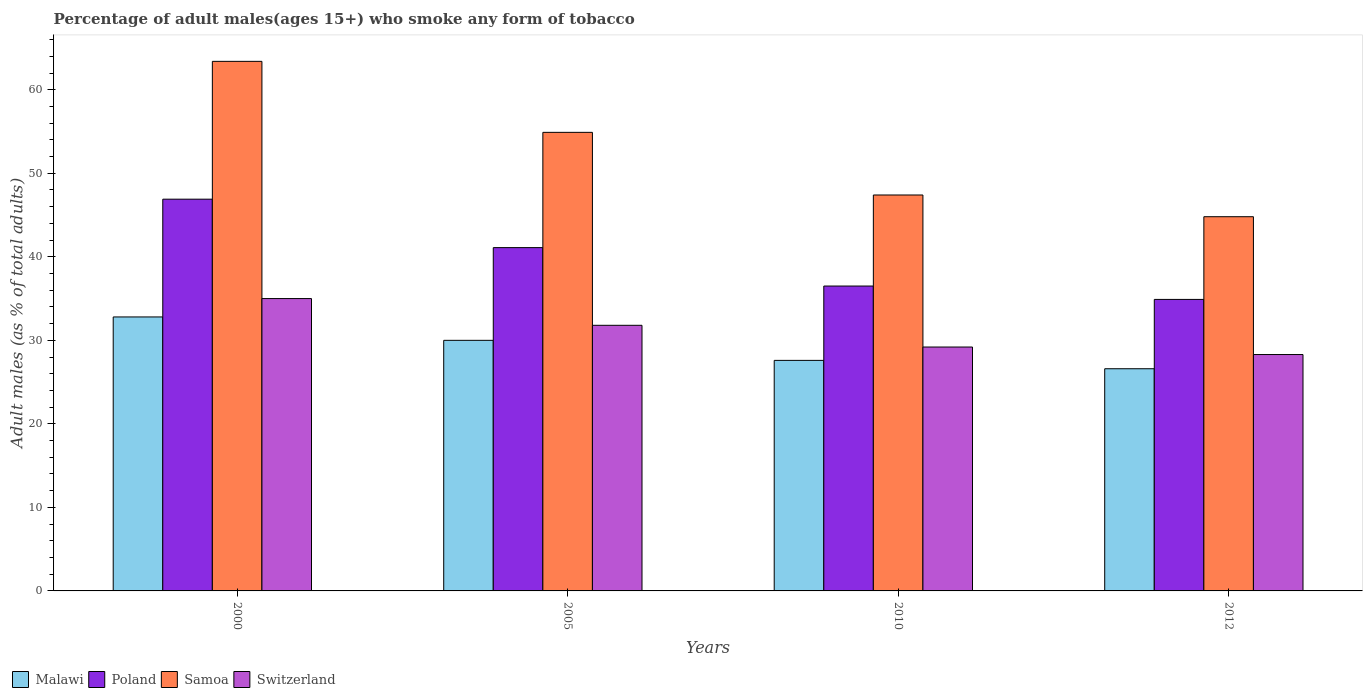How many groups of bars are there?
Give a very brief answer. 4. Are the number of bars on each tick of the X-axis equal?
Keep it short and to the point. Yes. How many bars are there on the 1st tick from the right?
Offer a very short reply. 4. What is the percentage of adult males who smoke in Samoa in 2012?
Ensure brevity in your answer.  44.8. Across all years, what is the minimum percentage of adult males who smoke in Samoa?
Keep it short and to the point. 44.8. In which year was the percentage of adult males who smoke in Switzerland minimum?
Your answer should be very brief. 2012. What is the total percentage of adult males who smoke in Switzerland in the graph?
Provide a succinct answer. 124.3. What is the difference between the percentage of adult males who smoke in Poland in 2000 and that in 2005?
Keep it short and to the point. 5.8. What is the difference between the percentage of adult males who smoke in Malawi in 2000 and the percentage of adult males who smoke in Switzerland in 2005?
Make the answer very short. 1. What is the average percentage of adult males who smoke in Samoa per year?
Offer a terse response. 52.62. What is the ratio of the percentage of adult males who smoke in Switzerland in 2005 to that in 2012?
Provide a short and direct response. 1.12. What is the difference between the highest and the second highest percentage of adult males who smoke in Poland?
Your answer should be compact. 5.8. What is the difference between the highest and the lowest percentage of adult males who smoke in Switzerland?
Your answer should be compact. 6.7. What does the 2nd bar from the right in 2012 represents?
Provide a succinct answer. Samoa. Is it the case that in every year, the sum of the percentage of adult males who smoke in Malawi and percentage of adult males who smoke in Samoa is greater than the percentage of adult males who smoke in Switzerland?
Keep it short and to the point. Yes. How many bars are there?
Give a very brief answer. 16. Are all the bars in the graph horizontal?
Your answer should be very brief. No. Are the values on the major ticks of Y-axis written in scientific E-notation?
Provide a short and direct response. No. Does the graph contain any zero values?
Ensure brevity in your answer.  No. What is the title of the graph?
Provide a short and direct response. Percentage of adult males(ages 15+) who smoke any form of tobacco. What is the label or title of the X-axis?
Offer a very short reply. Years. What is the label or title of the Y-axis?
Offer a very short reply. Adult males (as % of total adults). What is the Adult males (as % of total adults) in Malawi in 2000?
Make the answer very short. 32.8. What is the Adult males (as % of total adults) of Poland in 2000?
Your answer should be very brief. 46.9. What is the Adult males (as % of total adults) in Samoa in 2000?
Make the answer very short. 63.4. What is the Adult males (as % of total adults) in Malawi in 2005?
Keep it short and to the point. 30. What is the Adult males (as % of total adults) in Poland in 2005?
Ensure brevity in your answer.  41.1. What is the Adult males (as % of total adults) in Samoa in 2005?
Offer a very short reply. 54.9. What is the Adult males (as % of total adults) of Switzerland in 2005?
Give a very brief answer. 31.8. What is the Adult males (as % of total adults) of Malawi in 2010?
Offer a very short reply. 27.6. What is the Adult males (as % of total adults) of Poland in 2010?
Offer a very short reply. 36.5. What is the Adult males (as % of total adults) in Samoa in 2010?
Provide a short and direct response. 47.4. What is the Adult males (as % of total adults) of Switzerland in 2010?
Offer a very short reply. 29.2. What is the Adult males (as % of total adults) of Malawi in 2012?
Your answer should be compact. 26.6. What is the Adult males (as % of total adults) of Poland in 2012?
Offer a very short reply. 34.9. What is the Adult males (as % of total adults) in Samoa in 2012?
Offer a very short reply. 44.8. What is the Adult males (as % of total adults) of Switzerland in 2012?
Offer a terse response. 28.3. Across all years, what is the maximum Adult males (as % of total adults) of Malawi?
Provide a short and direct response. 32.8. Across all years, what is the maximum Adult males (as % of total adults) in Poland?
Provide a succinct answer. 46.9. Across all years, what is the maximum Adult males (as % of total adults) in Samoa?
Offer a very short reply. 63.4. Across all years, what is the minimum Adult males (as % of total adults) of Malawi?
Give a very brief answer. 26.6. Across all years, what is the minimum Adult males (as % of total adults) of Poland?
Offer a very short reply. 34.9. Across all years, what is the minimum Adult males (as % of total adults) of Samoa?
Keep it short and to the point. 44.8. Across all years, what is the minimum Adult males (as % of total adults) in Switzerland?
Your answer should be compact. 28.3. What is the total Adult males (as % of total adults) of Malawi in the graph?
Keep it short and to the point. 117. What is the total Adult males (as % of total adults) in Poland in the graph?
Offer a very short reply. 159.4. What is the total Adult males (as % of total adults) in Samoa in the graph?
Provide a short and direct response. 210.5. What is the total Adult males (as % of total adults) of Switzerland in the graph?
Offer a very short reply. 124.3. What is the difference between the Adult males (as % of total adults) in Poland in 2000 and that in 2005?
Provide a short and direct response. 5.8. What is the difference between the Adult males (as % of total adults) of Switzerland in 2000 and that in 2005?
Keep it short and to the point. 3.2. What is the difference between the Adult males (as % of total adults) of Poland in 2000 and that in 2010?
Provide a succinct answer. 10.4. What is the difference between the Adult males (as % of total adults) of Samoa in 2000 and that in 2010?
Provide a succinct answer. 16. What is the difference between the Adult males (as % of total adults) in Switzerland in 2000 and that in 2010?
Give a very brief answer. 5.8. What is the difference between the Adult males (as % of total adults) of Malawi in 2000 and that in 2012?
Offer a very short reply. 6.2. What is the difference between the Adult males (as % of total adults) in Malawi in 2005 and that in 2010?
Give a very brief answer. 2.4. What is the difference between the Adult males (as % of total adults) of Switzerland in 2005 and that in 2010?
Your answer should be very brief. 2.6. What is the difference between the Adult males (as % of total adults) of Samoa in 2005 and that in 2012?
Keep it short and to the point. 10.1. What is the difference between the Adult males (as % of total adults) of Switzerland in 2005 and that in 2012?
Offer a very short reply. 3.5. What is the difference between the Adult males (as % of total adults) of Malawi in 2010 and that in 2012?
Your answer should be compact. 1. What is the difference between the Adult males (as % of total adults) in Samoa in 2010 and that in 2012?
Make the answer very short. 2.6. What is the difference between the Adult males (as % of total adults) of Malawi in 2000 and the Adult males (as % of total adults) of Poland in 2005?
Ensure brevity in your answer.  -8.3. What is the difference between the Adult males (as % of total adults) of Malawi in 2000 and the Adult males (as % of total adults) of Samoa in 2005?
Keep it short and to the point. -22.1. What is the difference between the Adult males (as % of total adults) of Malawi in 2000 and the Adult males (as % of total adults) of Switzerland in 2005?
Your response must be concise. 1. What is the difference between the Adult males (as % of total adults) of Poland in 2000 and the Adult males (as % of total adults) of Samoa in 2005?
Your answer should be very brief. -8. What is the difference between the Adult males (as % of total adults) in Samoa in 2000 and the Adult males (as % of total adults) in Switzerland in 2005?
Your answer should be compact. 31.6. What is the difference between the Adult males (as % of total adults) of Malawi in 2000 and the Adult males (as % of total adults) of Poland in 2010?
Your answer should be very brief. -3.7. What is the difference between the Adult males (as % of total adults) in Malawi in 2000 and the Adult males (as % of total adults) in Samoa in 2010?
Provide a succinct answer. -14.6. What is the difference between the Adult males (as % of total adults) of Malawi in 2000 and the Adult males (as % of total adults) of Switzerland in 2010?
Ensure brevity in your answer.  3.6. What is the difference between the Adult males (as % of total adults) of Poland in 2000 and the Adult males (as % of total adults) of Samoa in 2010?
Keep it short and to the point. -0.5. What is the difference between the Adult males (as % of total adults) in Poland in 2000 and the Adult males (as % of total adults) in Switzerland in 2010?
Your response must be concise. 17.7. What is the difference between the Adult males (as % of total adults) in Samoa in 2000 and the Adult males (as % of total adults) in Switzerland in 2010?
Offer a very short reply. 34.2. What is the difference between the Adult males (as % of total adults) in Malawi in 2000 and the Adult males (as % of total adults) in Samoa in 2012?
Provide a succinct answer. -12. What is the difference between the Adult males (as % of total adults) in Malawi in 2000 and the Adult males (as % of total adults) in Switzerland in 2012?
Offer a terse response. 4.5. What is the difference between the Adult males (as % of total adults) in Poland in 2000 and the Adult males (as % of total adults) in Samoa in 2012?
Keep it short and to the point. 2.1. What is the difference between the Adult males (as % of total adults) of Samoa in 2000 and the Adult males (as % of total adults) of Switzerland in 2012?
Give a very brief answer. 35.1. What is the difference between the Adult males (as % of total adults) of Malawi in 2005 and the Adult males (as % of total adults) of Poland in 2010?
Offer a terse response. -6.5. What is the difference between the Adult males (as % of total adults) in Malawi in 2005 and the Adult males (as % of total adults) in Samoa in 2010?
Provide a short and direct response. -17.4. What is the difference between the Adult males (as % of total adults) in Poland in 2005 and the Adult males (as % of total adults) in Switzerland in 2010?
Your answer should be compact. 11.9. What is the difference between the Adult males (as % of total adults) of Samoa in 2005 and the Adult males (as % of total adults) of Switzerland in 2010?
Provide a short and direct response. 25.7. What is the difference between the Adult males (as % of total adults) in Malawi in 2005 and the Adult males (as % of total adults) in Poland in 2012?
Your answer should be very brief. -4.9. What is the difference between the Adult males (as % of total adults) in Malawi in 2005 and the Adult males (as % of total adults) in Samoa in 2012?
Offer a terse response. -14.8. What is the difference between the Adult males (as % of total adults) of Malawi in 2005 and the Adult males (as % of total adults) of Switzerland in 2012?
Provide a succinct answer. 1.7. What is the difference between the Adult males (as % of total adults) in Poland in 2005 and the Adult males (as % of total adults) in Switzerland in 2012?
Your answer should be very brief. 12.8. What is the difference between the Adult males (as % of total adults) in Samoa in 2005 and the Adult males (as % of total adults) in Switzerland in 2012?
Provide a short and direct response. 26.6. What is the difference between the Adult males (as % of total adults) of Malawi in 2010 and the Adult males (as % of total adults) of Samoa in 2012?
Keep it short and to the point. -17.2. What is the difference between the Adult males (as % of total adults) of Malawi in 2010 and the Adult males (as % of total adults) of Switzerland in 2012?
Offer a terse response. -0.7. What is the difference between the Adult males (as % of total adults) of Poland in 2010 and the Adult males (as % of total adults) of Samoa in 2012?
Give a very brief answer. -8.3. What is the difference between the Adult males (as % of total adults) in Poland in 2010 and the Adult males (as % of total adults) in Switzerland in 2012?
Make the answer very short. 8.2. What is the average Adult males (as % of total adults) in Malawi per year?
Your response must be concise. 29.25. What is the average Adult males (as % of total adults) of Poland per year?
Offer a terse response. 39.85. What is the average Adult males (as % of total adults) in Samoa per year?
Make the answer very short. 52.62. What is the average Adult males (as % of total adults) of Switzerland per year?
Your answer should be very brief. 31.07. In the year 2000, what is the difference between the Adult males (as % of total adults) in Malawi and Adult males (as % of total adults) in Poland?
Your response must be concise. -14.1. In the year 2000, what is the difference between the Adult males (as % of total adults) of Malawi and Adult males (as % of total adults) of Samoa?
Provide a short and direct response. -30.6. In the year 2000, what is the difference between the Adult males (as % of total adults) in Malawi and Adult males (as % of total adults) in Switzerland?
Make the answer very short. -2.2. In the year 2000, what is the difference between the Adult males (as % of total adults) in Poland and Adult males (as % of total adults) in Samoa?
Your response must be concise. -16.5. In the year 2000, what is the difference between the Adult males (as % of total adults) in Poland and Adult males (as % of total adults) in Switzerland?
Offer a terse response. 11.9. In the year 2000, what is the difference between the Adult males (as % of total adults) in Samoa and Adult males (as % of total adults) in Switzerland?
Give a very brief answer. 28.4. In the year 2005, what is the difference between the Adult males (as % of total adults) of Malawi and Adult males (as % of total adults) of Samoa?
Offer a very short reply. -24.9. In the year 2005, what is the difference between the Adult males (as % of total adults) of Malawi and Adult males (as % of total adults) of Switzerland?
Ensure brevity in your answer.  -1.8. In the year 2005, what is the difference between the Adult males (as % of total adults) in Samoa and Adult males (as % of total adults) in Switzerland?
Provide a short and direct response. 23.1. In the year 2010, what is the difference between the Adult males (as % of total adults) in Malawi and Adult males (as % of total adults) in Samoa?
Your response must be concise. -19.8. In the year 2010, what is the difference between the Adult males (as % of total adults) of Malawi and Adult males (as % of total adults) of Switzerland?
Your answer should be compact. -1.6. In the year 2010, what is the difference between the Adult males (as % of total adults) in Samoa and Adult males (as % of total adults) in Switzerland?
Your answer should be very brief. 18.2. In the year 2012, what is the difference between the Adult males (as % of total adults) in Malawi and Adult males (as % of total adults) in Samoa?
Your answer should be very brief. -18.2. In the year 2012, what is the difference between the Adult males (as % of total adults) in Poland and Adult males (as % of total adults) in Switzerland?
Offer a very short reply. 6.6. What is the ratio of the Adult males (as % of total adults) of Malawi in 2000 to that in 2005?
Provide a short and direct response. 1.09. What is the ratio of the Adult males (as % of total adults) in Poland in 2000 to that in 2005?
Provide a short and direct response. 1.14. What is the ratio of the Adult males (as % of total adults) of Samoa in 2000 to that in 2005?
Keep it short and to the point. 1.15. What is the ratio of the Adult males (as % of total adults) in Switzerland in 2000 to that in 2005?
Keep it short and to the point. 1.1. What is the ratio of the Adult males (as % of total adults) of Malawi in 2000 to that in 2010?
Give a very brief answer. 1.19. What is the ratio of the Adult males (as % of total adults) of Poland in 2000 to that in 2010?
Your response must be concise. 1.28. What is the ratio of the Adult males (as % of total adults) of Samoa in 2000 to that in 2010?
Your answer should be very brief. 1.34. What is the ratio of the Adult males (as % of total adults) in Switzerland in 2000 to that in 2010?
Offer a very short reply. 1.2. What is the ratio of the Adult males (as % of total adults) of Malawi in 2000 to that in 2012?
Provide a succinct answer. 1.23. What is the ratio of the Adult males (as % of total adults) in Poland in 2000 to that in 2012?
Your answer should be very brief. 1.34. What is the ratio of the Adult males (as % of total adults) of Samoa in 2000 to that in 2012?
Offer a terse response. 1.42. What is the ratio of the Adult males (as % of total adults) in Switzerland in 2000 to that in 2012?
Give a very brief answer. 1.24. What is the ratio of the Adult males (as % of total adults) of Malawi in 2005 to that in 2010?
Make the answer very short. 1.09. What is the ratio of the Adult males (as % of total adults) of Poland in 2005 to that in 2010?
Your response must be concise. 1.13. What is the ratio of the Adult males (as % of total adults) in Samoa in 2005 to that in 2010?
Give a very brief answer. 1.16. What is the ratio of the Adult males (as % of total adults) of Switzerland in 2005 to that in 2010?
Make the answer very short. 1.09. What is the ratio of the Adult males (as % of total adults) in Malawi in 2005 to that in 2012?
Provide a succinct answer. 1.13. What is the ratio of the Adult males (as % of total adults) of Poland in 2005 to that in 2012?
Provide a short and direct response. 1.18. What is the ratio of the Adult males (as % of total adults) in Samoa in 2005 to that in 2012?
Provide a succinct answer. 1.23. What is the ratio of the Adult males (as % of total adults) of Switzerland in 2005 to that in 2012?
Your response must be concise. 1.12. What is the ratio of the Adult males (as % of total adults) in Malawi in 2010 to that in 2012?
Offer a very short reply. 1.04. What is the ratio of the Adult males (as % of total adults) of Poland in 2010 to that in 2012?
Offer a very short reply. 1.05. What is the ratio of the Adult males (as % of total adults) in Samoa in 2010 to that in 2012?
Keep it short and to the point. 1.06. What is the ratio of the Adult males (as % of total adults) in Switzerland in 2010 to that in 2012?
Keep it short and to the point. 1.03. What is the difference between the highest and the second highest Adult males (as % of total adults) of Malawi?
Offer a very short reply. 2.8. What is the difference between the highest and the second highest Adult males (as % of total adults) in Samoa?
Your answer should be very brief. 8.5. What is the difference between the highest and the second highest Adult males (as % of total adults) of Switzerland?
Offer a terse response. 3.2. 